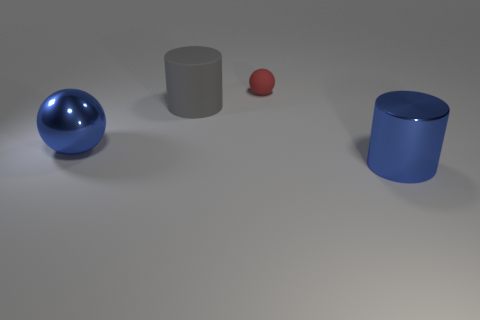What is the lighting setup like in this scene? The lighting in this scene appears to be diffused, creating soft shadows for the objects. There are no distinct or harsh shadows, suggesting that the light source is not highly directional, and the overall illumination is quite even across the surface. 